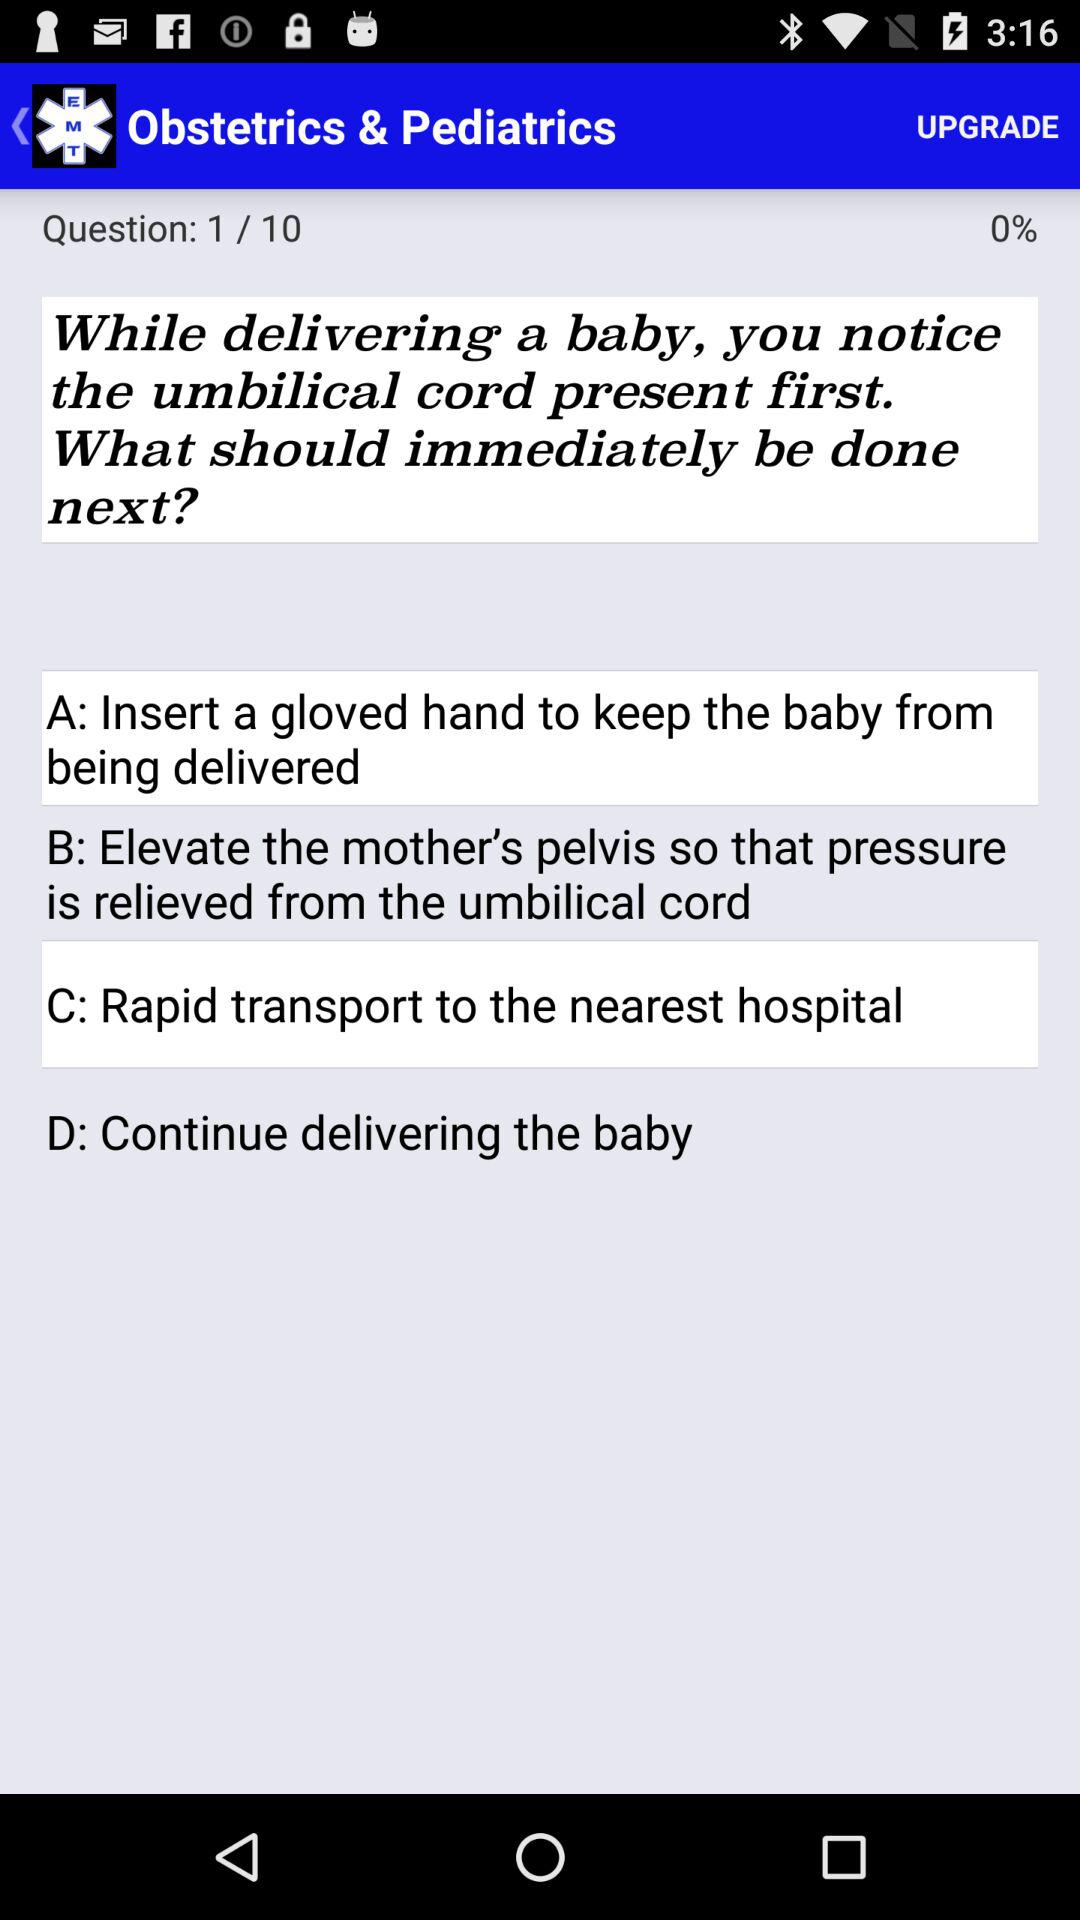How many questions in total are there? There are 10 questions. 